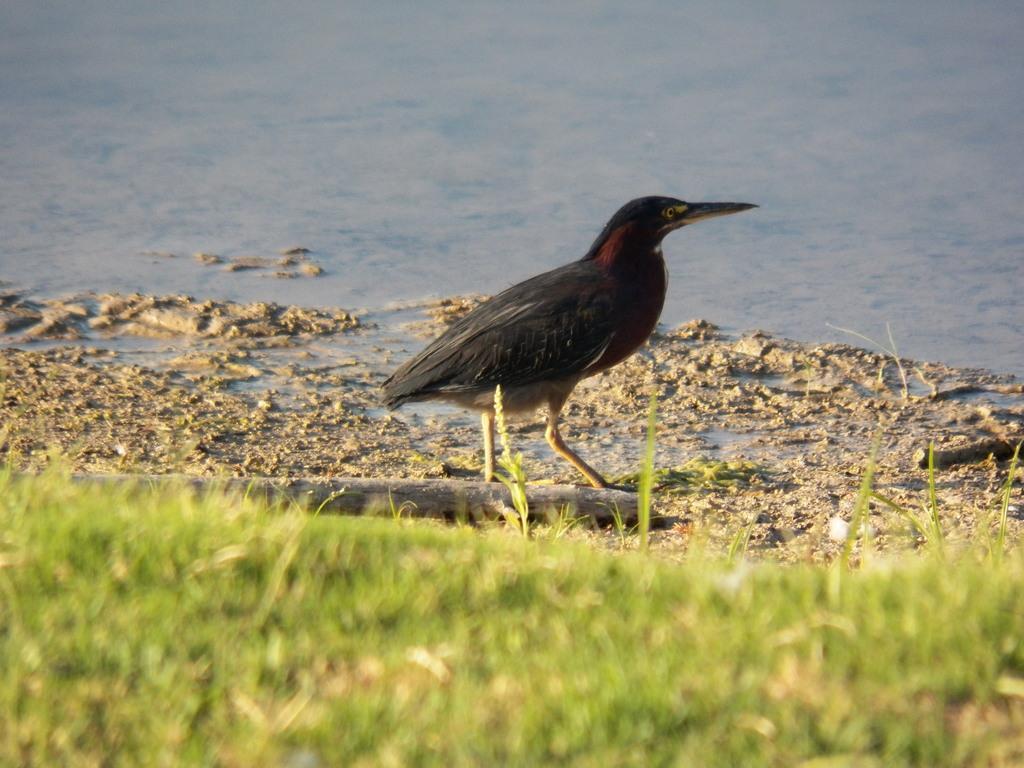In one or two sentences, can you explain what this image depicts? In the foreground of the image we can see the grass. In the middle of the image we can see a bird and the mud. On the top of the image we can see water body. 